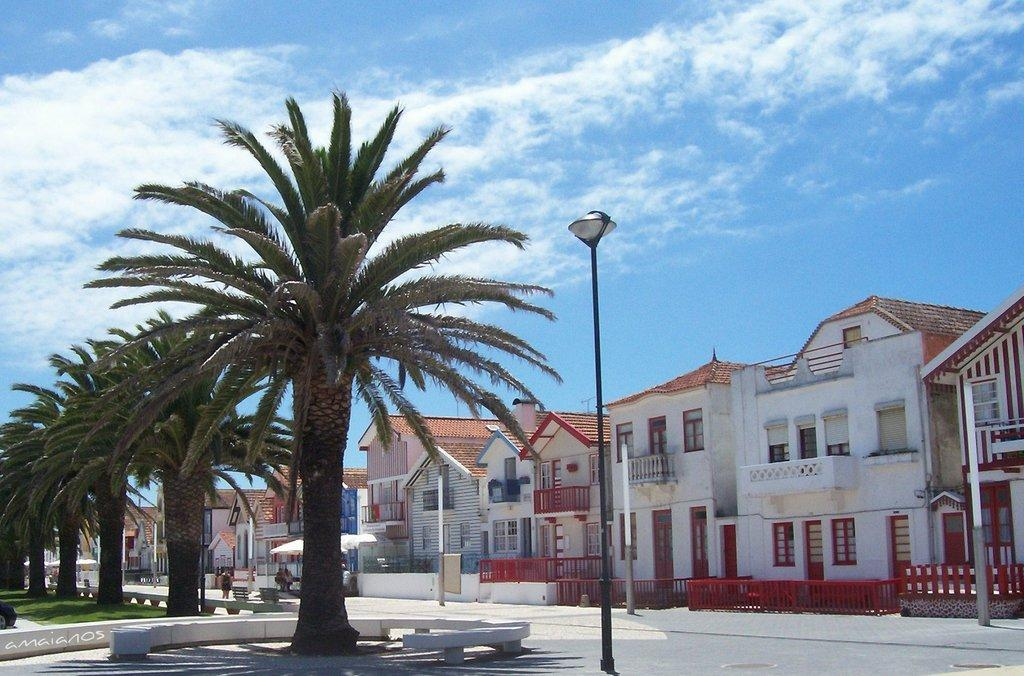What type of trees are in the middle of the image? There are coconut trees in the middle of the image. What is located in front of the coconut trees? There is a black and white lamp post in front of the trees. What can be seen in the background of the image? There are colorful small bungalow houses in the background of the image. What authority figure is guiding the morning walk in the image? There is no authority figure or morning walk depicted in the image. 